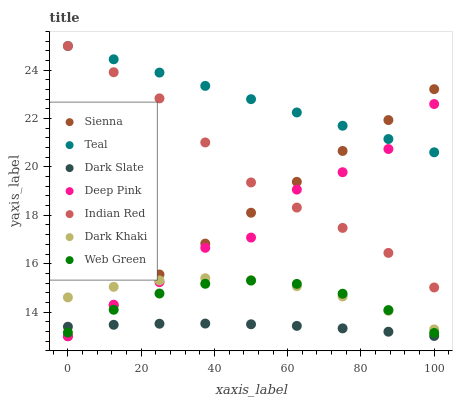Does Dark Slate have the minimum area under the curve?
Answer yes or no. Yes. Does Teal have the maximum area under the curve?
Answer yes or no. Yes. Does Deep Pink have the minimum area under the curve?
Answer yes or no. No. Does Deep Pink have the maximum area under the curve?
Answer yes or no. No. Is Sienna the smoothest?
Answer yes or no. Yes. Is Deep Pink the roughest?
Answer yes or no. Yes. Is Teal the smoothest?
Answer yes or no. No. Is Teal the roughest?
Answer yes or no. No. Does Deep Pink have the lowest value?
Answer yes or no. Yes. Does Teal have the lowest value?
Answer yes or no. No. Does Indian Red have the highest value?
Answer yes or no. Yes. Does Deep Pink have the highest value?
Answer yes or no. No. Is Dark Khaki less than Indian Red?
Answer yes or no. Yes. Is Indian Red greater than Dark Slate?
Answer yes or no. Yes. Does Deep Pink intersect Dark Slate?
Answer yes or no. Yes. Is Deep Pink less than Dark Slate?
Answer yes or no. No. Is Deep Pink greater than Dark Slate?
Answer yes or no. No. Does Dark Khaki intersect Indian Red?
Answer yes or no. No. 